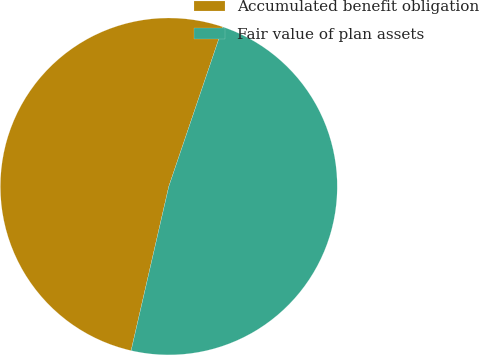Convert chart to OTSL. <chart><loc_0><loc_0><loc_500><loc_500><pie_chart><fcel>Accumulated benefit obligation<fcel>Fair value of plan assets<nl><fcel>51.61%<fcel>48.39%<nl></chart> 